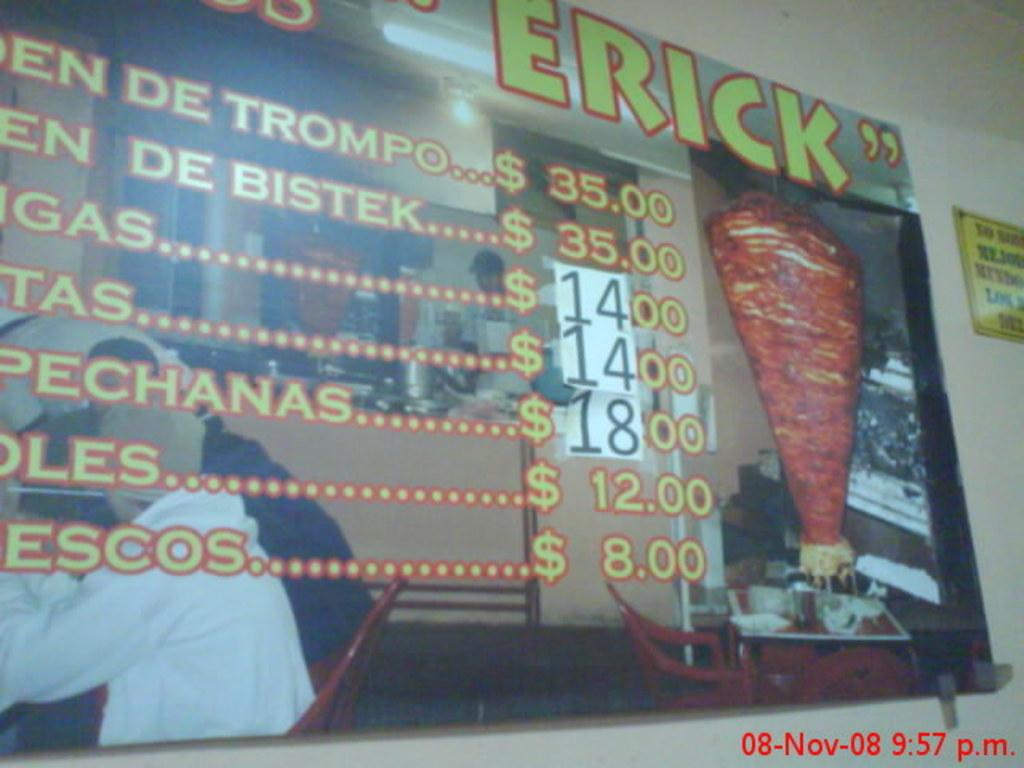<image>
Share a concise interpretation of the image provided. A photograph of a menu taken on November 8th, 2008 at 9:57 PM. 